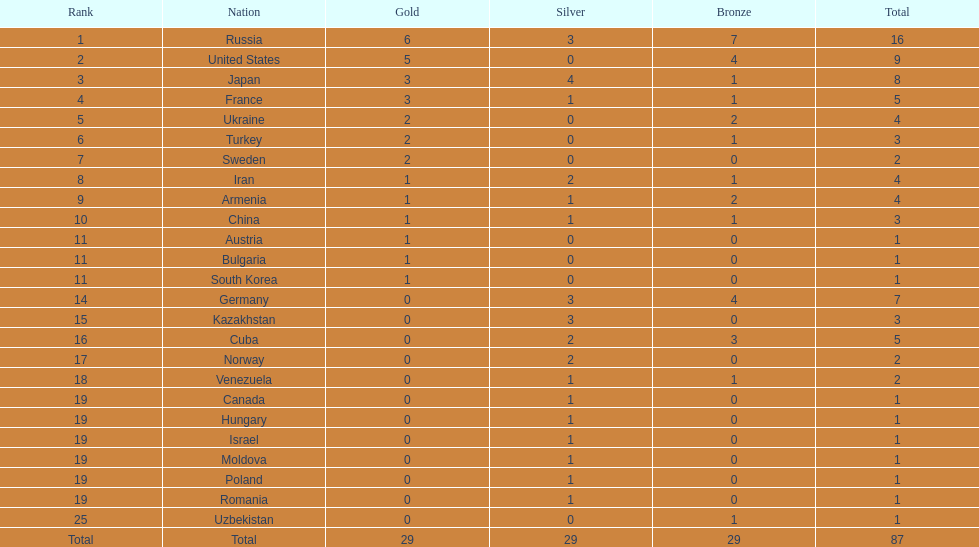Which country possesses one gold medal but none in silver and bronze? Austria. 